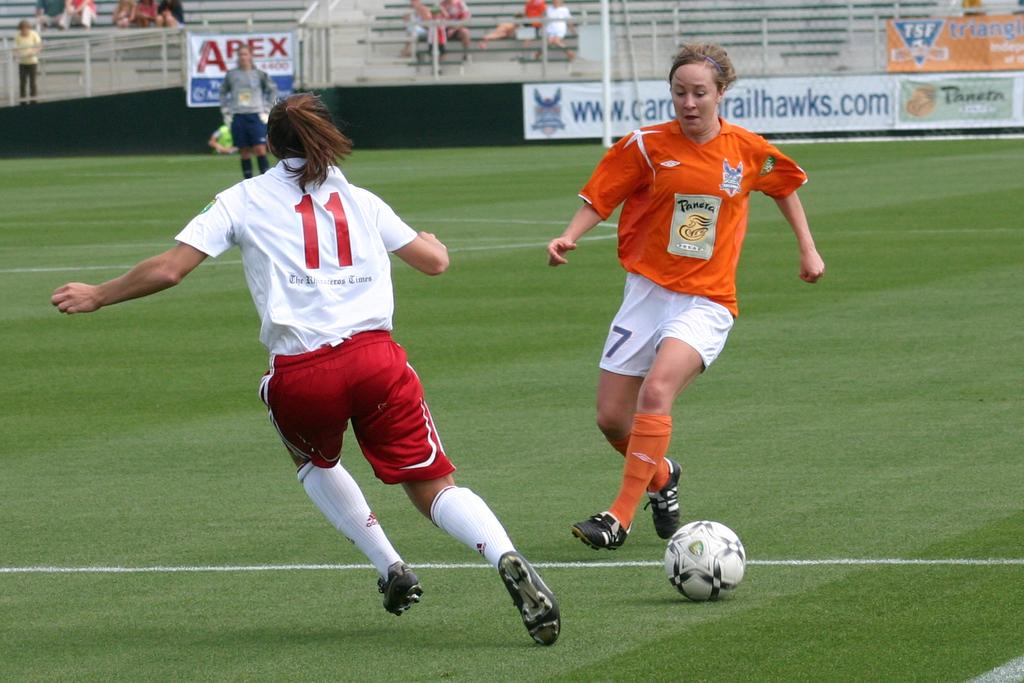<image>
Describe the image concisely. Player number 7 in orange dribbles the ball as player number 11 in white defends. 